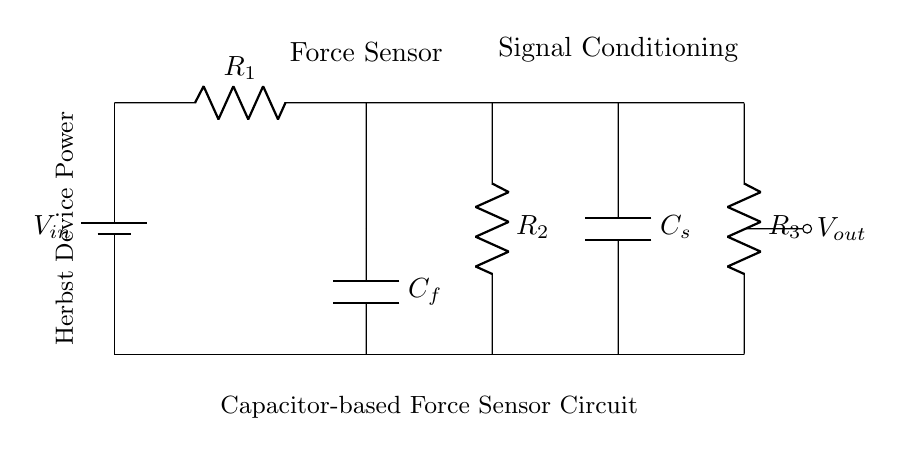What is the total number of resistors in the circuit? There are three resistors identified as R1, R2, and R3 in the circuit diagram.
Answer: 3 What is the role of the capacitor labeled C_f? The capacitor C_f acts as a force sensor, detecting changes in force applied to the Herbst device.
Answer: Force sensor Which component is responsible for signal conditioning in this circuit? The second capacitor C_s is responsible for signal conditioning, smoothing out the signal before it is sent to the output.
Answer: C_s What is the output voltage node labeled as? The output voltage node is labeled V_out, indicating the voltage measurement point after the signal conditioning.
Answer: V_out What happens to the charge in capacitor C_f during operation? The charge in capacitor C_f will change based on variations in force applied, affecting how much current flows through the resistors.
Answer: Changes Which resistor is connected directly to the capacitor C_s? The resistor R3 is directly connected to the capacitor C_s in this circuit diagram.
Answer: R3 What is the power source for the entire circuit? The circuit is powered by the battery labeled V_in, providing the necessary voltage for its operation.
Answer: V_in 